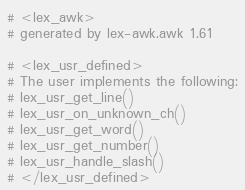<code> <loc_0><loc_0><loc_500><loc_500><_Awk_># <lex_awk>
# generated by lex-awk.awk 1.61

# <lex_usr_defined>
# The user implements the following:
# lex_usr_get_line()
# lex_usr_on_unknown_ch()
# lex_usr_get_word()
# lex_usr_get_number()
# lex_usr_handle_slash()
# </lex_usr_defined>
</code> 